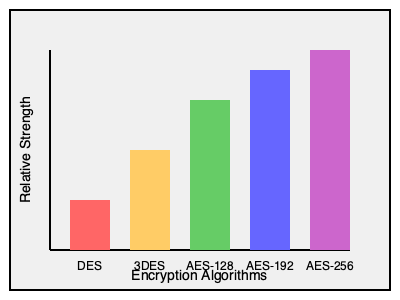Based on the graph showing the relative strength of encryption algorithms, which algorithm would be most suitable for securing communication protocols in industrial automation systems where maximum security is required? To determine the most suitable encryption algorithm for securing communication protocols in industrial automation systems, we need to analyze the relative strength of each algorithm shown in the graph:

1. DES (Data Encryption Standard): The shortest bar indicates it has the lowest relative strength among the options. It's an older algorithm and no longer considered secure for sensitive applications.

2. 3DES (Triple DES): The second shortest bar shows it's stronger than DES but weaker than the AES variants. It's still used in some legacy systems but is being phased out.

3. AES-128 (Advanced Encryption Standard with 128-bit key): The middle bar indicates it's significantly stronger than DES and 3DES. It's widely used and considered secure for many applications.

4. AES-192 (AES with 192-bit key): The second tallest bar shows it's even stronger than AES-128, offering a higher level of security.

5. AES-256 (AES with 256-bit key): The tallest bar indicates it has the highest relative strength among all options presented. It's considered the most secure and is often used for highly sensitive data and applications.

For industrial automation systems where maximum security is required, the strongest encryption algorithm should be chosen to protect against potential cyber threats and ensure the integrity and confidentiality of critical data and control signals.

Therefore, based on the information provided in the graph, AES-256 would be the most suitable algorithm for securing communication protocols in industrial automation systems requiring maximum security.
Answer: AES-256 